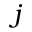Convert formula to latex. <formula><loc_0><loc_0><loc_500><loc_500>j</formula> 